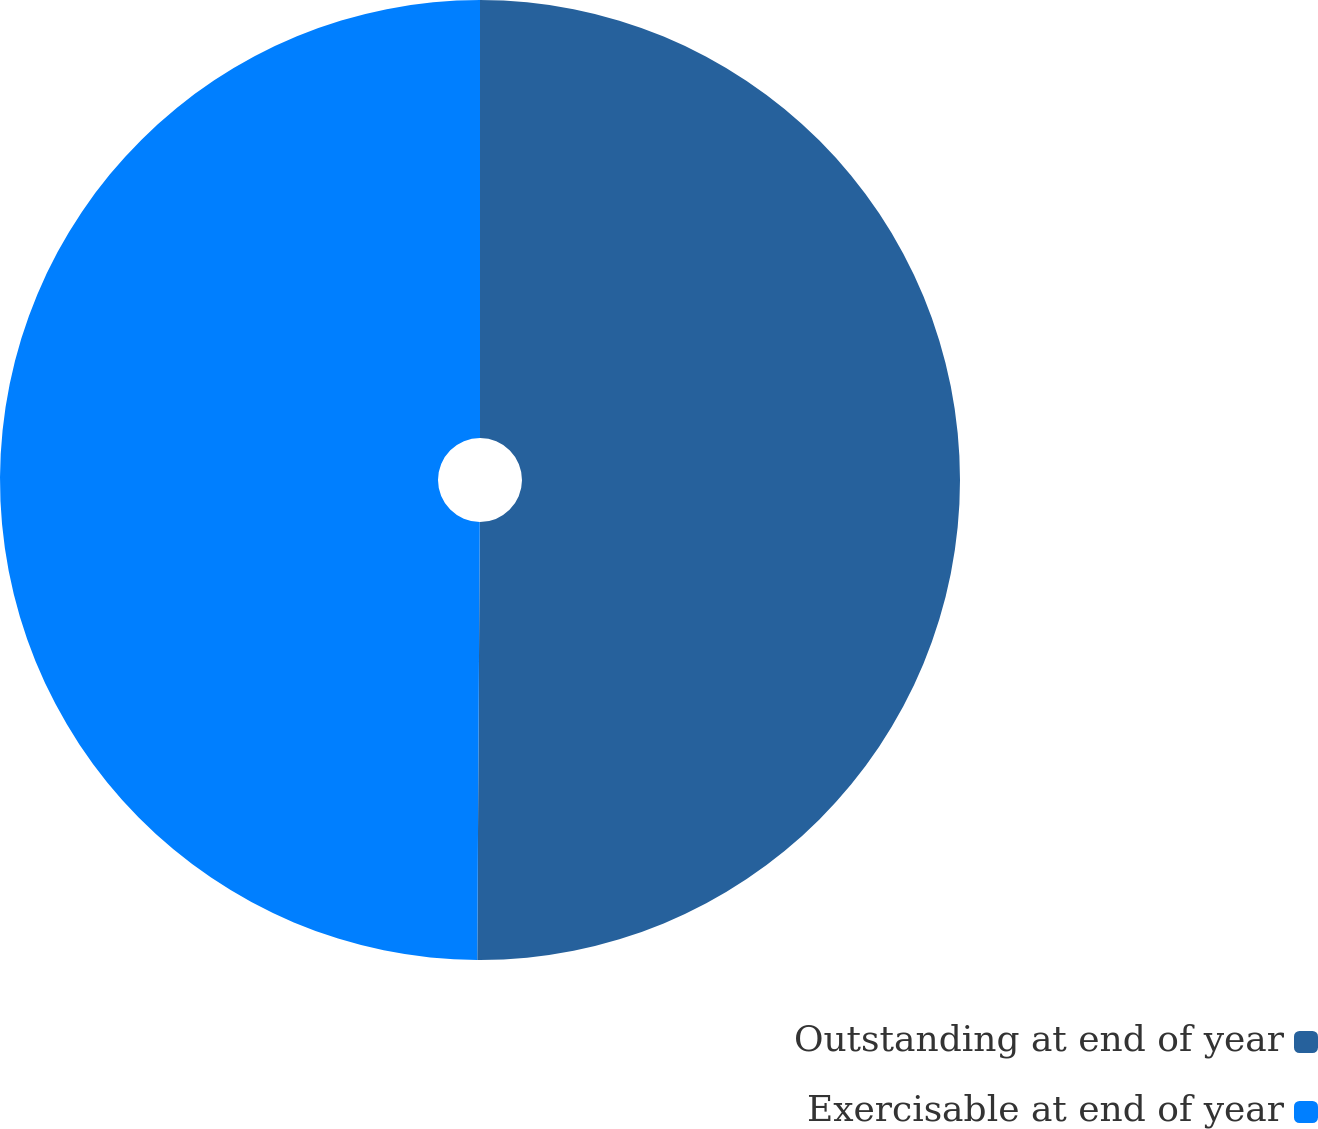Convert chart. <chart><loc_0><loc_0><loc_500><loc_500><pie_chart><fcel>Outstanding at end of year<fcel>Exercisable at end of year<nl><fcel>50.09%<fcel>49.91%<nl></chart> 